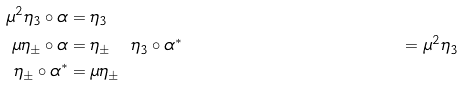Convert formula to latex. <formula><loc_0><loc_0><loc_500><loc_500>\mu ^ { 2 } \eta _ { 3 } \circ \alpha & = \eta _ { 3 } \\ \mu \eta _ { \pm } \circ \alpha & = \eta _ { \pm } \quad \eta _ { 3 } \circ \alpha ^ { * } & = \mu ^ { 2 } \eta _ { 3 } \\ \eta _ { \pm } \circ \alpha ^ { * } & = \mu \eta _ { \pm }</formula> 